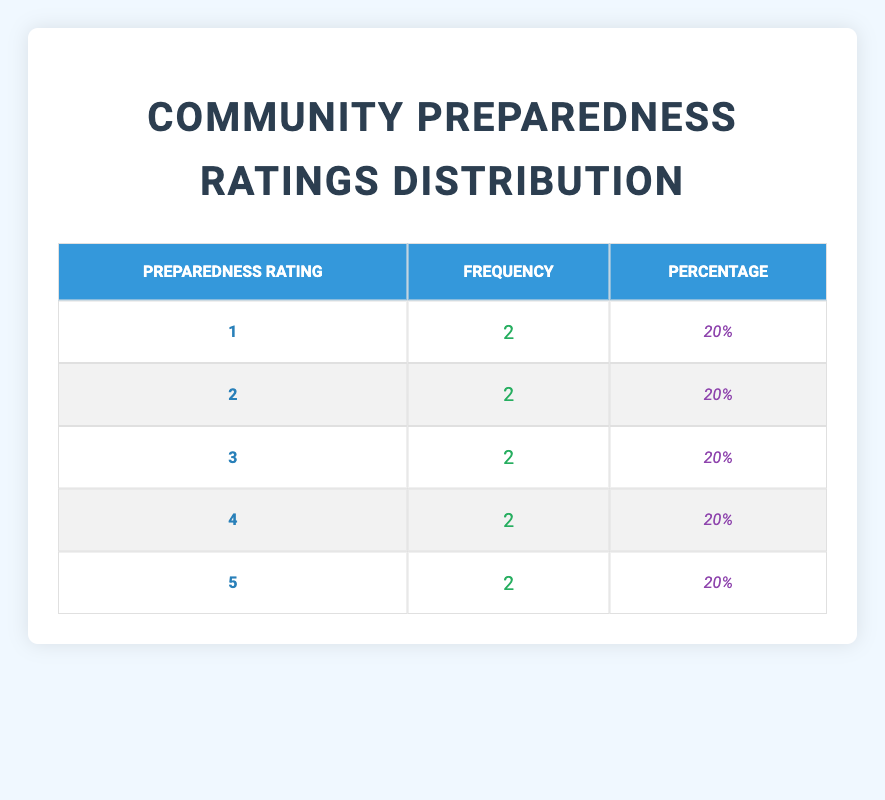What is the frequency of preparedness rating 3? The table shows that the frequency of preparedness rating 3 is listed under the "Frequency" column for rating 3, which is 2.
Answer: 2 What percentage of communities have a preparedness rating of 5? The table indicates that the percentage for preparedness rating 5 is listed as 20%. This is calculated by taking the frequency (2) for rating 5 and dividing it by the total number of communities (10) and multiplying by 100, which results in 20%.
Answer: 20% How many communities have a preparedness rating lower than 4? To find communities with a rating lower than 4, we count the frequencies for ratings 1, 2, and 3, which are all 2 each. The total frequency for lower ratings is 2 + 2 + 2 = 6.
Answer: 6 Is there any community with a preparedness rating of 0? By checking the "Preparedness Rating" row in the table, we can see that there is no entry for a rating of 0, indicating that no communities have a rating of 0.
Answer: No What is the average preparedness rating across all communities? To calculate the average rating, we need to multiply each rating by its frequency: (1*2 + 2*2 + 3*2 + 4*2 + 5*2) / 10 = (2 + 4 + 6 + 8 + 10) / 10 = 30 / 10 = 3.
Answer: 3 Which rating has the highest number of communities? In the table, all ratings have the same frequency of 2. Therefore, no rating can be identified as having the highest number, as they are all equal.
Answer: None If we consider ratings of 4 and 5 together, what is their total frequency? The frequency of preparedness rating 4 is 2 and for rating 5 is also 2. Summing these frequencies gives us 2 + 2 = 4.
Answer: 4 Is the frequency distribution uniform across all preparedness ratings? Since the frequencies for all preparedness ratings are the same (2 for each) and have equal totals, we conclude that the distribution is uniform.
Answer: Yes What is the total number of communities assessed in the table? By summing the frequencies of each preparedness rating, we can determine the total number of communities: 2 + 2 + 2 + 2 + 2 = 10.
Answer: 10 